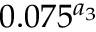Convert formula to latex. <formula><loc_0><loc_0><loc_500><loc_500>0 . 0 7 5 ^ { a _ { 3 } }</formula> 